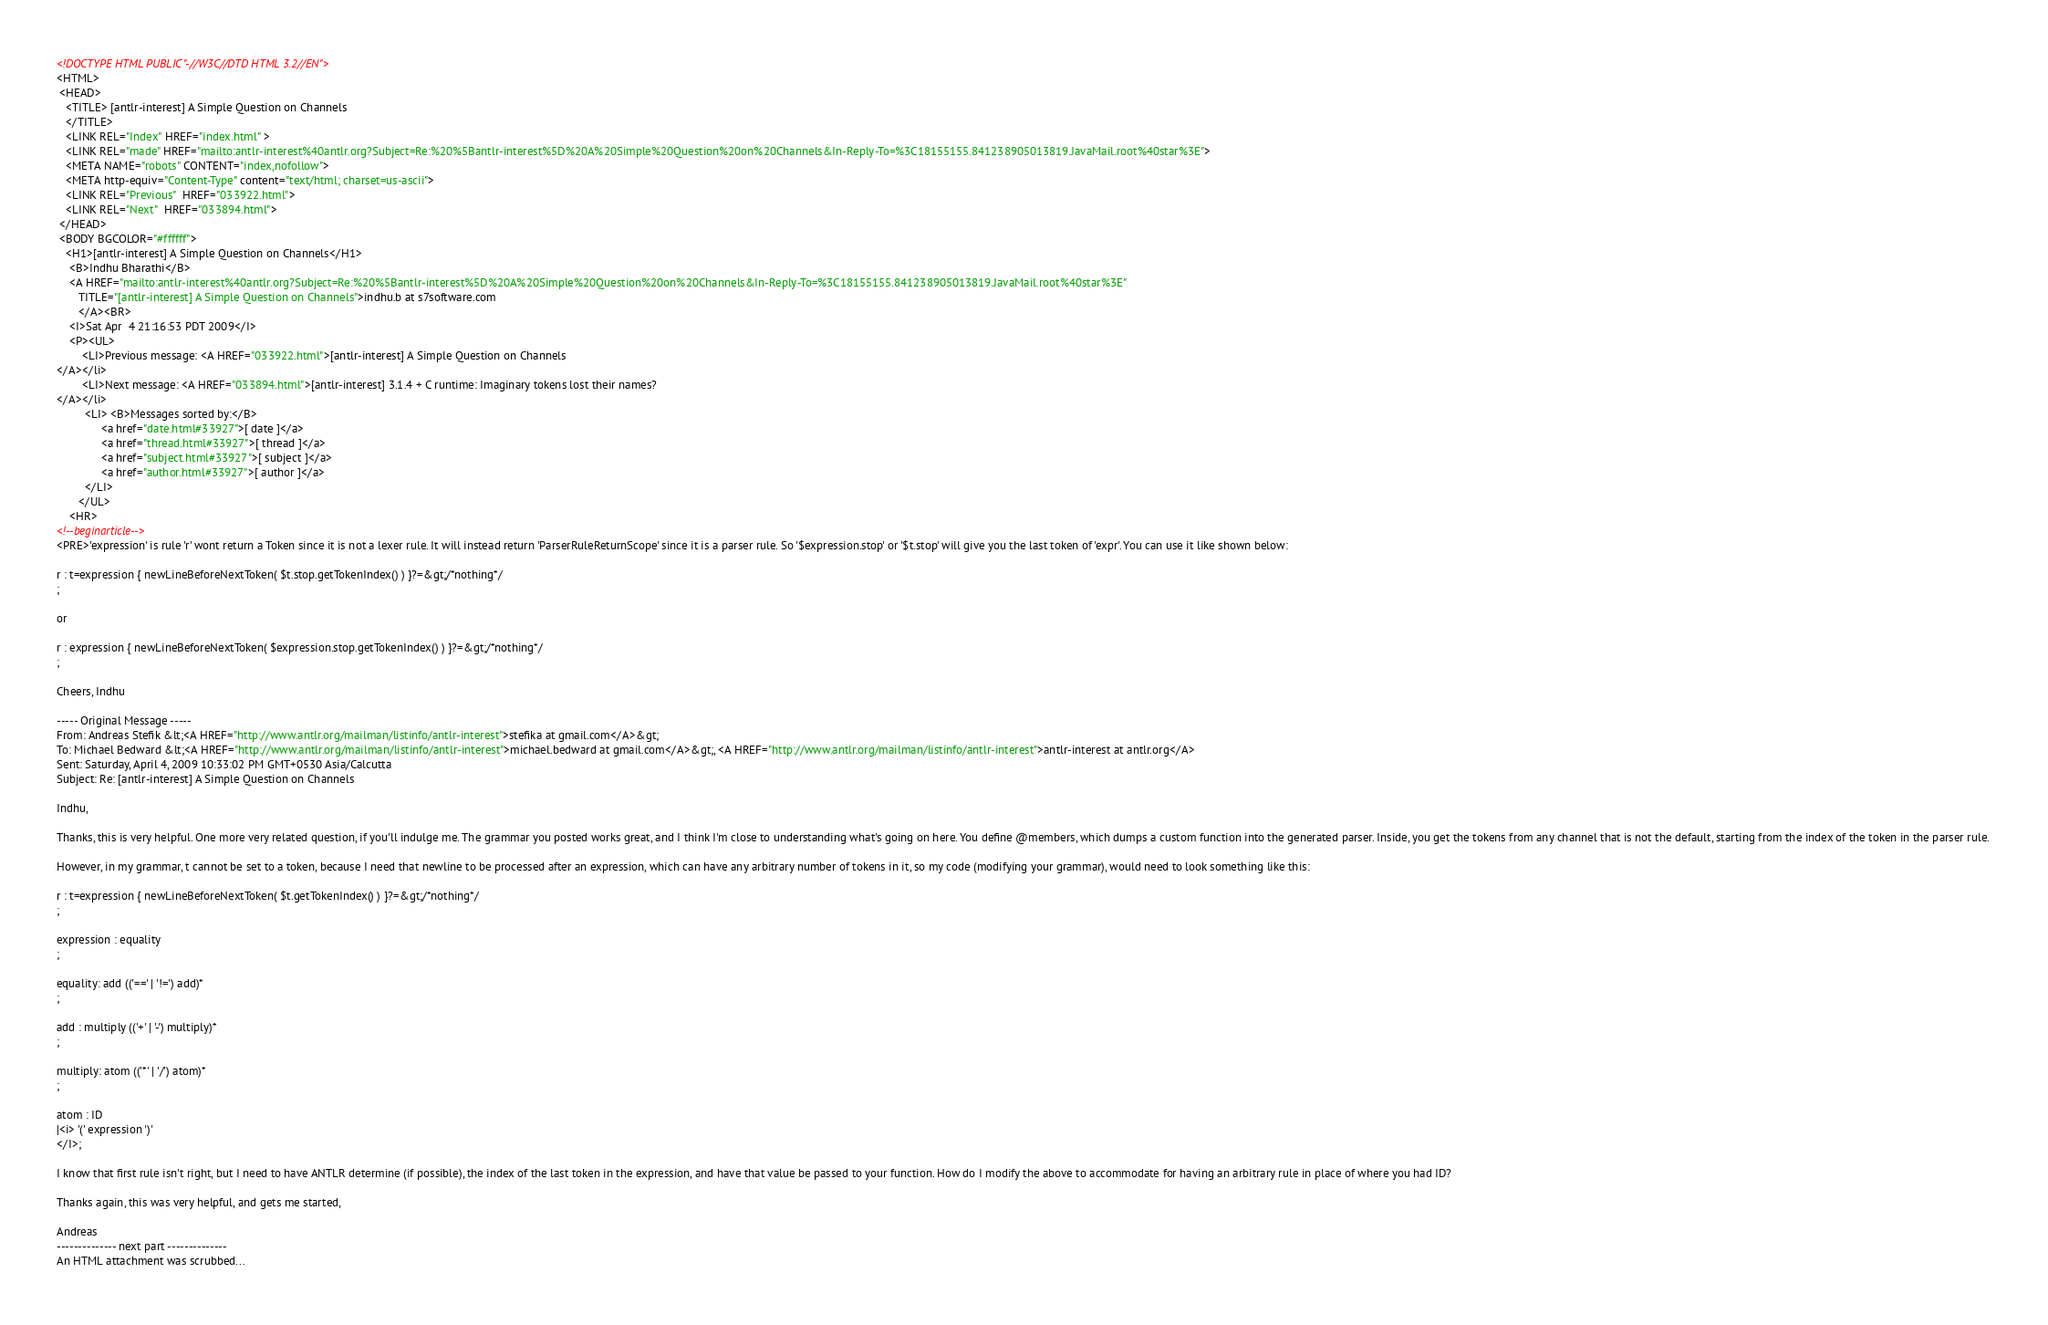Convert code to text. <code><loc_0><loc_0><loc_500><loc_500><_HTML_><!DOCTYPE HTML PUBLIC "-//W3C//DTD HTML 3.2//EN">
<HTML>
 <HEAD>
   <TITLE> [antlr-interest] A Simple Question on Channels
   </TITLE>
   <LINK REL="Index" HREF="index.html" >
   <LINK REL="made" HREF="mailto:antlr-interest%40antlr.org?Subject=Re:%20%5Bantlr-interest%5D%20A%20Simple%20Question%20on%20Channels&In-Reply-To=%3C18155155.841238905013819.JavaMail.root%40star%3E">
   <META NAME="robots" CONTENT="index,nofollow">
   <META http-equiv="Content-Type" content="text/html; charset=us-ascii">
   <LINK REL="Previous"  HREF="033922.html">
   <LINK REL="Next"  HREF="033894.html">
 </HEAD>
 <BODY BGCOLOR="#ffffff">
   <H1>[antlr-interest] A Simple Question on Channels</H1>
    <B>Indhu Bharathi</B> 
    <A HREF="mailto:antlr-interest%40antlr.org?Subject=Re:%20%5Bantlr-interest%5D%20A%20Simple%20Question%20on%20Channels&In-Reply-To=%3C18155155.841238905013819.JavaMail.root%40star%3E"
       TITLE="[antlr-interest] A Simple Question on Channels">indhu.b at s7software.com
       </A><BR>
    <I>Sat Apr  4 21:16:53 PDT 2009</I>
    <P><UL>
        <LI>Previous message: <A HREF="033922.html">[antlr-interest] A Simple Question on Channels
</A></li>
        <LI>Next message: <A HREF="033894.html">[antlr-interest] 3.1.4 + C runtime: Imaginary tokens lost their	names?
</A></li>
         <LI> <B>Messages sorted by:</B> 
              <a href="date.html#33927">[ date ]</a>
              <a href="thread.html#33927">[ thread ]</a>
              <a href="subject.html#33927">[ subject ]</a>
              <a href="author.html#33927">[ author ]</a>
         </LI>
       </UL>
    <HR>  
<!--beginarticle-->
<PRE>'expression' is rule 'r' wont return a Token since it is not a lexer rule. It will instead return 'ParserRuleReturnScope' since it is a parser rule. So '$expression.stop' or '$t.stop' will give you the last token of 'expr'. You can use it like shown below: 

r : t=expression { newLineBeforeNextToken( $t.stop.getTokenIndex() ) }?=&gt;/*nothing*/ 
; 

or 

r : expression { newLineBeforeNextToken( $expression.stop.getTokenIndex() ) }?=&gt;/*nothing*/ 
; 

Cheers, Indhu 

----- Original Message ----- 
From: Andreas Stefik &lt;<A HREF="http://www.antlr.org/mailman/listinfo/antlr-interest">stefika at gmail.com</A>&gt; 
To: Michael Bedward &lt;<A HREF="http://www.antlr.org/mailman/listinfo/antlr-interest">michael.bedward at gmail.com</A>&gt;, <A HREF="http://www.antlr.org/mailman/listinfo/antlr-interest">antlr-interest at antlr.org</A> 
Sent: Saturday, April 4, 2009 10:33:02 PM GMT+0530 Asia/Calcutta 
Subject: Re: [antlr-interest] A Simple Question on Channels 

Indhu, 

Thanks, this is very helpful. One more very related question, if you'll indulge me. The grammar you posted works great, and I think I'm close to understanding what's going on here. You define @members, which dumps a custom function into the generated parser. Inside, you get the tokens from any channel that is not the default, starting from the index of the token in the parser rule. 

However, in my grammar, t cannot be set to a token, because I need that newline to be processed after an expression, which can have any arbitrary number of tokens in it, so my code (modifying your grammar), would need to look something like this: 

r : t=expression { newLineBeforeNextToken( $t.getTokenIndex() ) }?=&gt;/*nothing*/ 
; 

expression : equality 
; 

equality: add (('==' | '!=') add)* 
; 

add : multiply (('+' | '-') multiply)* 
; 

multiply: atom (('*' | '/') atom)* 
; 

atom : ID 
|<i> '(' expression ')' 
</I>; 

I know that first rule isn't right, but I need to have ANTLR determine (if possible), the index of the last token in the expression, and have that value be passed to your function. How do I modify the above to accommodate for having an arbitrary rule in place of where you had ID? 

Thanks again, this was very helpful, and gets me started, 

Andreas 
-------------- next part --------------
An HTML attachment was scrubbed...</code> 